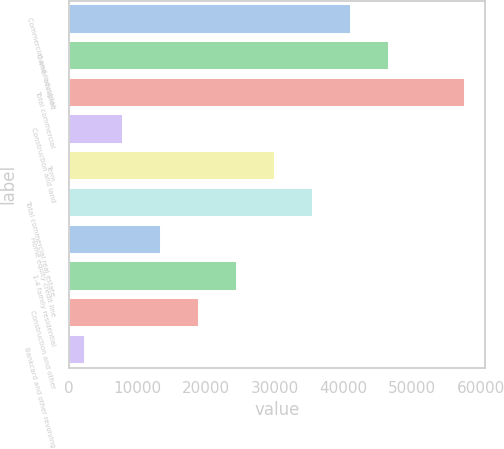<chart> <loc_0><loc_0><loc_500><loc_500><bar_chart><fcel>Commercial and industrial<fcel>Owner occupied<fcel>Total commercial<fcel>Construction and land<fcel>Term<fcel>Total commercial real estate<fcel>Home equity credit line<fcel>1-4 family residential<fcel>Construction and other<fcel>Bankcard and other revolving<nl><fcel>41118.9<fcel>46646.6<fcel>57702<fcel>7952.7<fcel>30063.5<fcel>35591.2<fcel>13480.4<fcel>24535.8<fcel>19008.1<fcel>2425<nl></chart> 